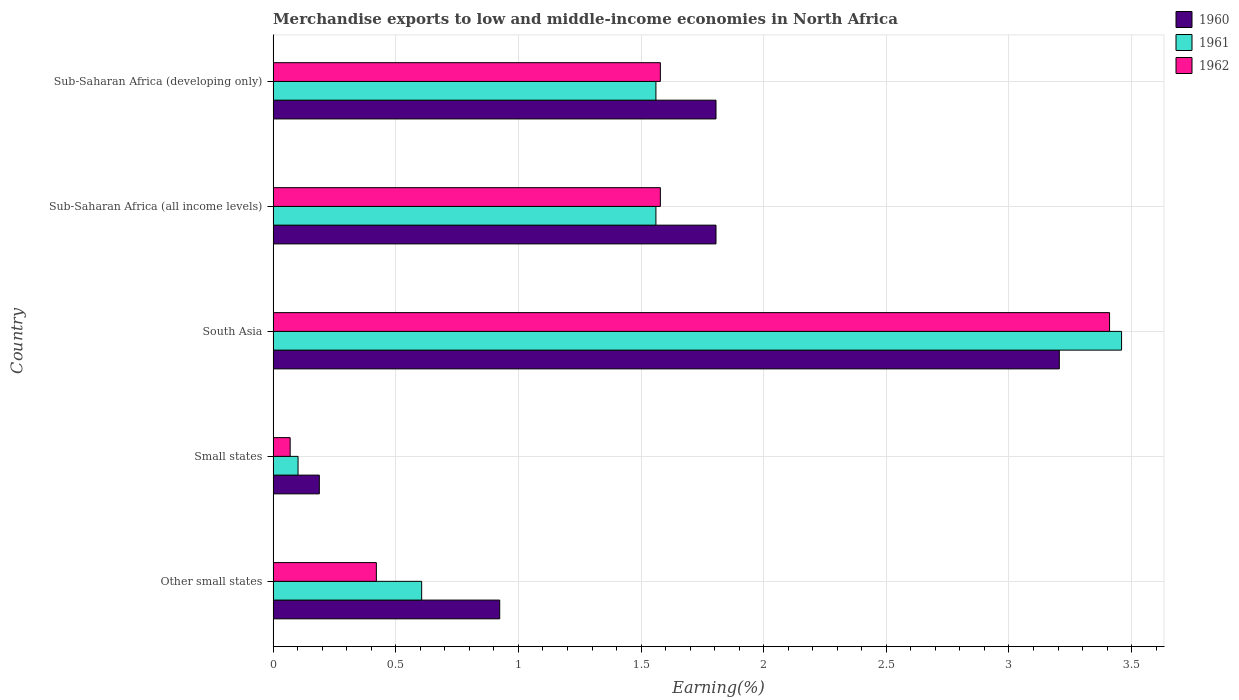How many different coloured bars are there?
Ensure brevity in your answer.  3. What is the percentage of amount earned from merchandise exports in 1962 in Other small states?
Provide a short and direct response. 0.42. Across all countries, what is the maximum percentage of amount earned from merchandise exports in 1962?
Offer a terse response. 3.41. Across all countries, what is the minimum percentage of amount earned from merchandise exports in 1961?
Provide a short and direct response. 0.1. In which country was the percentage of amount earned from merchandise exports in 1960 minimum?
Your answer should be very brief. Small states. What is the total percentage of amount earned from merchandise exports in 1960 in the graph?
Ensure brevity in your answer.  7.93. What is the difference between the percentage of amount earned from merchandise exports in 1962 in Small states and that in Sub-Saharan Africa (all income levels)?
Give a very brief answer. -1.51. What is the difference between the percentage of amount earned from merchandise exports in 1961 in Sub-Saharan Africa (developing only) and the percentage of amount earned from merchandise exports in 1962 in Sub-Saharan Africa (all income levels)?
Provide a short and direct response. -0.02. What is the average percentage of amount earned from merchandise exports in 1960 per country?
Your response must be concise. 1.59. What is the difference between the percentage of amount earned from merchandise exports in 1961 and percentage of amount earned from merchandise exports in 1960 in South Asia?
Offer a terse response. 0.25. What is the ratio of the percentage of amount earned from merchandise exports in 1960 in Small states to that in Sub-Saharan Africa (developing only)?
Make the answer very short. 0.1. Is the difference between the percentage of amount earned from merchandise exports in 1961 in Other small states and Small states greater than the difference between the percentage of amount earned from merchandise exports in 1960 in Other small states and Small states?
Ensure brevity in your answer.  No. What is the difference between the highest and the second highest percentage of amount earned from merchandise exports in 1961?
Keep it short and to the point. 1.9. What is the difference between the highest and the lowest percentage of amount earned from merchandise exports in 1960?
Keep it short and to the point. 3.02. Is the sum of the percentage of amount earned from merchandise exports in 1960 in Other small states and Sub-Saharan Africa (developing only) greater than the maximum percentage of amount earned from merchandise exports in 1962 across all countries?
Offer a very short reply. No. Is it the case that in every country, the sum of the percentage of amount earned from merchandise exports in 1961 and percentage of amount earned from merchandise exports in 1960 is greater than the percentage of amount earned from merchandise exports in 1962?
Keep it short and to the point. Yes. Are the values on the major ticks of X-axis written in scientific E-notation?
Offer a terse response. No. Where does the legend appear in the graph?
Ensure brevity in your answer.  Top right. How many legend labels are there?
Offer a terse response. 3. How are the legend labels stacked?
Give a very brief answer. Vertical. What is the title of the graph?
Your answer should be compact. Merchandise exports to low and middle-income economies in North Africa. Does "2010" appear as one of the legend labels in the graph?
Provide a succinct answer. No. What is the label or title of the X-axis?
Give a very brief answer. Earning(%). What is the Earning(%) in 1960 in Other small states?
Offer a very short reply. 0.92. What is the Earning(%) in 1961 in Other small states?
Offer a terse response. 0.61. What is the Earning(%) in 1962 in Other small states?
Your answer should be very brief. 0.42. What is the Earning(%) in 1960 in Small states?
Ensure brevity in your answer.  0.19. What is the Earning(%) of 1961 in Small states?
Offer a terse response. 0.1. What is the Earning(%) in 1962 in Small states?
Your answer should be very brief. 0.07. What is the Earning(%) in 1960 in South Asia?
Offer a terse response. 3.21. What is the Earning(%) in 1961 in South Asia?
Keep it short and to the point. 3.46. What is the Earning(%) of 1962 in South Asia?
Make the answer very short. 3.41. What is the Earning(%) in 1960 in Sub-Saharan Africa (all income levels)?
Give a very brief answer. 1.81. What is the Earning(%) in 1961 in Sub-Saharan Africa (all income levels)?
Provide a succinct answer. 1.56. What is the Earning(%) in 1962 in Sub-Saharan Africa (all income levels)?
Your answer should be compact. 1.58. What is the Earning(%) of 1960 in Sub-Saharan Africa (developing only)?
Your response must be concise. 1.81. What is the Earning(%) in 1961 in Sub-Saharan Africa (developing only)?
Ensure brevity in your answer.  1.56. What is the Earning(%) in 1962 in Sub-Saharan Africa (developing only)?
Give a very brief answer. 1.58. Across all countries, what is the maximum Earning(%) in 1960?
Offer a very short reply. 3.21. Across all countries, what is the maximum Earning(%) of 1961?
Make the answer very short. 3.46. Across all countries, what is the maximum Earning(%) of 1962?
Keep it short and to the point. 3.41. Across all countries, what is the minimum Earning(%) in 1960?
Your answer should be compact. 0.19. Across all countries, what is the minimum Earning(%) in 1961?
Make the answer very short. 0.1. Across all countries, what is the minimum Earning(%) of 1962?
Provide a short and direct response. 0.07. What is the total Earning(%) in 1960 in the graph?
Provide a short and direct response. 7.93. What is the total Earning(%) in 1961 in the graph?
Keep it short and to the point. 7.29. What is the total Earning(%) of 1962 in the graph?
Keep it short and to the point. 7.06. What is the difference between the Earning(%) in 1960 in Other small states and that in Small states?
Your answer should be very brief. 0.74. What is the difference between the Earning(%) of 1961 in Other small states and that in Small states?
Offer a terse response. 0.5. What is the difference between the Earning(%) in 1962 in Other small states and that in Small states?
Make the answer very short. 0.35. What is the difference between the Earning(%) in 1960 in Other small states and that in South Asia?
Your response must be concise. -2.28. What is the difference between the Earning(%) in 1961 in Other small states and that in South Asia?
Offer a terse response. -2.85. What is the difference between the Earning(%) of 1962 in Other small states and that in South Asia?
Your answer should be compact. -2.99. What is the difference between the Earning(%) of 1960 in Other small states and that in Sub-Saharan Africa (all income levels)?
Ensure brevity in your answer.  -0.88. What is the difference between the Earning(%) in 1961 in Other small states and that in Sub-Saharan Africa (all income levels)?
Your answer should be compact. -0.96. What is the difference between the Earning(%) in 1962 in Other small states and that in Sub-Saharan Africa (all income levels)?
Provide a short and direct response. -1.16. What is the difference between the Earning(%) of 1960 in Other small states and that in Sub-Saharan Africa (developing only)?
Offer a very short reply. -0.88. What is the difference between the Earning(%) of 1961 in Other small states and that in Sub-Saharan Africa (developing only)?
Give a very brief answer. -0.96. What is the difference between the Earning(%) in 1962 in Other small states and that in Sub-Saharan Africa (developing only)?
Your answer should be compact. -1.16. What is the difference between the Earning(%) in 1960 in Small states and that in South Asia?
Your response must be concise. -3.02. What is the difference between the Earning(%) in 1961 in Small states and that in South Asia?
Provide a succinct answer. -3.36. What is the difference between the Earning(%) of 1962 in Small states and that in South Asia?
Offer a very short reply. -3.34. What is the difference between the Earning(%) in 1960 in Small states and that in Sub-Saharan Africa (all income levels)?
Ensure brevity in your answer.  -1.62. What is the difference between the Earning(%) in 1961 in Small states and that in Sub-Saharan Africa (all income levels)?
Offer a very short reply. -1.46. What is the difference between the Earning(%) in 1962 in Small states and that in Sub-Saharan Africa (all income levels)?
Your answer should be very brief. -1.51. What is the difference between the Earning(%) of 1960 in Small states and that in Sub-Saharan Africa (developing only)?
Your response must be concise. -1.62. What is the difference between the Earning(%) in 1961 in Small states and that in Sub-Saharan Africa (developing only)?
Provide a short and direct response. -1.46. What is the difference between the Earning(%) of 1962 in Small states and that in Sub-Saharan Africa (developing only)?
Provide a short and direct response. -1.51. What is the difference between the Earning(%) in 1960 in South Asia and that in Sub-Saharan Africa (all income levels)?
Offer a very short reply. 1.4. What is the difference between the Earning(%) of 1961 in South Asia and that in Sub-Saharan Africa (all income levels)?
Your response must be concise. 1.9. What is the difference between the Earning(%) of 1962 in South Asia and that in Sub-Saharan Africa (all income levels)?
Provide a short and direct response. 1.83. What is the difference between the Earning(%) in 1960 in South Asia and that in Sub-Saharan Africa (developing only)?
Your answer should be very brief. 1.4. What is the difference between the Earning(%) of 1961 in South Asia and that in Sub-Saharan Africa (developing only)?
Offer a terse response. 1.9. What is the difference between the Earning(%) of 1962 in South Asia and that in Sub-Saharan Africa (developing only)?
Make the answer very short. 1.83. What is the difference between the Earning(%) of 1962 in Sub-Saharan Africa (all income levels) and that in Sub-Saharan Africa (developing only)?
Offer a terse response. 0. What is the difference between the Earning(%) of 1960 in Other small states and the Earning(%) of 1961 in Small states?
Give a very brief answer. 0.82. What is the difference between the Earning(%) in 1960 in Other small states and the Earning(%) in 1962 in Small states?
Provide a short and direct response. 0.85. What is the difference between the Earning(%) of 1961 in Other small states and the Earning(%) of 1962 in Small states?
Provide a short and direct response. 0.54. What is the difference between the Earning(%) of 1960 in Other small states and the Earning(%) of 1961 in South Asia?
Offer a very short reply. -2.54. What is the difference between the Earning(%) in 1960 in Other small states and the Earning(%) in 1962 in South Asia?
Keep it short and to the point. -2.49. What is the difference between the Earning(%) of 1961 in Other small states and the Earning(%) of 1962 in South Asia?
Your answer should be very brief. -2.8. What is the difference between the Earning(%) in 1960 in Other small states and the Earning(%) in 1961 in Sub-Saharan Africa (all income levels)?
Your answer should be compact. -0.64. What is the difference between the Earning(%) in 1960 in Other small states and the Earning(%) in 1962 in Sub-Saharan Africa (all income levels)?
Give a very brief answer. -0.66. What is the difference between the Earning(%) in 1961 in Other small states and the Earning(%) in 1962 in Sub-Saharan Africa (all income levels)?
Provide a short and direct response. -0.97. What is the difference between the Earning(%) of 1960 in Other small states and the Earning(%) of 1961 in Sub-Saharan Africa (developing only)?
Keep it short and to the point. -0.64. What is the difference between the Earning(%) of 1960 in Other small states and the Earning(%) of 1962 in Sub-Saharan Africa (developing only)?
Your response must be concise. -0.66. What is the difference between the Earning(%) in 1961 in Other small states and the Earning(%) in 1962 in Sub-Saharan Africa (developing only)?
Provide a short and direct response. -0.97. What is the difference between the Earning(%) in 1960 in Small states and the Earning(%) in 1961 in South Asia?
Your answer should be very brief. -3.27. What is the difference between the Earning(%) of 1960 in Small states and the Earning(%) of 1962 in South Asia?
Your response must be concise. -3.22. What is the difference between the Earning(%) of 1961 in Small states and the Earning(%) of 1962 in South Asia?
Provide a short and direct response. -3.31. What is the difference between the Earning(%) in 1960 in Small states and the Earning(%) in 1961 in Sub-Saharan Africa (all income levels)?
Provide a short and direct response. -1.37. What is the difference between the Earning(%) in 1960 in Small states and the Earning(%) in 1962 in Sub-Saharan Africa (all income levels)?
Give a very brief answer. -1.39. What is the difference between the Earning(%) of 1961 in Small states and the Earning(%) of 1962 in Sub-Saharan Africa (all income levels)?
Provide a short and direct response. -1.48. What is the difference between the Earning(%) in 1960 in Small states and the Earning(%) in 1961 in Sub-Saharan Africa (developing only)?
Your response must be concise. -1.37. What is the difference between the Earning(%) in 1960 in Small states and the Earning(%) in 1962 in Sub-Saharan Africa (developing only)?
Give a very brief answer. -1.39. What is the difference between the Earning(%) in 1961 in Small states and the Earning(%) in 1962 in Sub-Saharan Africa (developing only)?
Your response must be concise. -1.48. What is the difference between the Earning(%) in 1960 in South Asia and the Earning(%) in 1961 in Sub-Saharan Africa (all income levels)?
Give a very brief answer. 1.64. What is the difference between the Earning(%) in 1960 in South Asia and the Earning(%) in 1962 in Sub-Saharan Africa (all income levels)?
Your answer should be compact. 1.63. What is the difference between the Earning(%) of 1961 in South Asia and the Earning(%) of 1962 in Sub-Saharan Africa (all income levels)?
Offer a very short reply. 1.88. What is the difference between the Earning(%) in 1960 in South Asia and the Earning(%) in 1961 in Sub-Saharan Africa (developing only)?
Keep it short and to the point. 1.64. What is the difference between the Earning(%) in 1960 in South Asia and the Earning(%) in 1962 in Sub-Saharan Africa (developing only)?
Keep it short and to the point. 1.63. What is the difference between the Earning(%) of 1961 in South Asia and the Earning(%) of 1962 in Sub-Saharan Africa (developing only)?
Offer a terse response. 1.88. What is the difference between the Earning(%) of 1960 in Sub-Saharan Africa (all income levels) and the Earning(%) of 1961 in Sub-Saharan Africa (developing only)?
Keep it short and to the point. 0.24. What is the difference between the Earning(%) in 1960 in Sub-Saharan Africa (all income levels) and the Earning(%) in 1962 in Sub-Saharan Africa (developing only)?
Offer a very short reply. 0.23. What is the difference between the Earning(%) in 1961 in Sub-Saharan Africa (all income levels) and the Earning(%) in 1962 in Sub-Saharan Africa (developing only)?
Your response must be concise. -0.02. What is the average Earning(%) of 1960 per country?
Make the answer very short. 1.59. What is the average Earning(%) of 1961 per country?
Give a very brief answer. 1.46. What is the average Earning(%) in 1962 per country?
Your answer should be compact. 1.41. What is the difference between the Earning(%) in 1960 and Earning(%) in 1961 in Other small states?
Provide a short and direct response. 0.32. What is the difference between the Earning(%) in 1960 and Earning(%) in 1962 in Other small states?
Ensure brevity in your answer.  0.5. What is the difference between the Earning(%) in 1961 and Earning(%) in 1962 in Other small states?
Keep it short and to the point. 0.18. What is the difference between the Earning(%) in 1960 and Earning(%) in 1961 in Small states?
Give a very brief answer. 0.09. What is the difference between the Earning(%) of 1960 and Earning(%) of 1962 in Small states?
Provide a succinct answer. 0.12. What is the difference between the Earning(%) in 1961 and Earning(%) in 1962 in Small states?
Make the answer very short. 0.03. What is the difference between the Earning(%) in 1960 and Earning(%) in 1961 in South Asia?
Your answer should be very brief. -0.25. What is the difference between the Earning(%) of 1960 and Earning(%) of 1962 in South Asia?
Give a very brief answer. -0.2. What is the difference between the Earning(%) in 1961 and Earning(%) in 1962 in South Asia?
Ensure brevity in your answer.  0.05. What is the difference between the Earning(%) in 1960 and Earning(%) in 1961 in Sub-Saharan Africa (all income levels)?
Make the answer very short. 0.24. What is the difference between the Earning(%) of 1960 and Earning(%) of 1962 in Sub-Saharan Africa (all income levels)?
Ensure brevity in your answer.  0.23. What is the difference between the Earning(%) in 1961 and Earning(%) in 1962 in Sub-Saharan Africa (all income levels)?
Your answer should be very brief. -0.02. What is the difference between the Earning(%) of 1960 and Earning(%) of 1961 in Sub-Saharan Africa (developing only)?
Offer a terse response. 0.24. What is the difference between the Earning(%) in 1960 and Earning(%) in 1962 in Sub-Saharan Africa (developing only)?
Provide a succinct answer. 0.23. What is the difference between the Earning(%) in 1961 and Earning(%) in 1962 in Sub-Saharan Africa (developing only)?
Give a very brief answer. -0.02. What is the ratio of the Earning(%) in 1960 in Other small states to that in Small states?
Offer a terse response. 4.9. What is the ratio of the Earning(%) in 1961 in Other small states to that in Small states?
Your answer should be compact. 5.96. What is the ratio of the Earning(%) of 1962 in Other small states to that in Small states?
Ensure brevity in your answer.  6.06. What is the ratio of the Earning(%) of 1960 in Other small states to that in South Asia?
Your answer should be very brief. 0.29. What is the ratio of the Earning(%) in 1961 in Other small states to that in South Asia?
Provide a short and direct response. 0.18. What is the ratio of the Earning(%) in 1962 in Other small states to that in South Asia?
Provide a short and direct response. 0.12. What is the ratio of the Earning(%) of 1960 in Other small states to that in Sub-Saharan Africa (all income levels)?
Your answer should be very brief. 0.51. What is the ratio of the Earning(%) in 1961 in Other small states to that in Sub-Saharan Africa (all income levels)?
Provide a short and direct response. 0.39. What is the ratio of the Earning(%) of 1962 in Other small states to that in Sub-Saharan Africa (all income levels)?
Give a very brief answer. 0.27. What is the ratio of the Earning(%) in 1960 in Other small states to that in Sub-Saharan Africa (developing only)?
Make the answer very short. 0.51. What is the ratio of the Earning(%) in 1961 in Other small states to that in Sub-Saharan Africa (developing only)?
Make the answer very short. 0.39. What is the ratio of the Earning(%) in 1962 in Other small states to that in Sub-Saharan Africa (developing only)?
Your answer should be very brief. 0.27. What is the ratio of the Earning(%) in 1960 in Small states to that in South Asia?
Provide a short and direct response. 0.06. What is the ratio of the Earning(%) of 1961 in Small states to that in South Asia?
Your answer should be compact. 0.03. What is the ratio of the Earning(%) of 1962 in Small states to that in South Asia?
Make the answer very short. 0.02. What is the ratio of the Earning(%) in 1960 in Small states to that in Sub-Saharan Africa (all income levels)?
Your answer should be very brief. 0.1. What is the ratio of the Earning(%) in 1961 in Small states to that in Sub-Saharan Africa (all income levels)?
Offer a very short reply. 0.07. What is the ratio of the Earning(%) in 1962 in Small states to that in Sub-Saharan Africa (all income levels)?
Your answer should be very brief. 0.04. What is the ratio of the Earning(%) in 1960 in Small states to that in Sub-Saharan Africa (developing only)?
Offer a very short reply. 0.1. What is the ratio of the Earning(%) in 1961 in Small states to that in Sub-Saharan Africa (developing only)?
Give a very brief answer. 0.07. What is the ratio of the Earning(%) of 1962 in Small states to that in Sub-Saharan Africa (developing only)?
Offer a very short reply. 0.04. What is the ratio of the Earning(%) in 1960 in South Asia to that in Sub-Saharan Africa (all income levels)?
Your answer should be compact. 1.78. What is the ratio of the Earning(%) of 1961 in South Asia to that in Sub-Saharan Africa (all income levels)?
Your answer should be very brief. 2.22. What is the ratio of the Earning(%) of 1962 in South Asia to that in Sub-Saharan Africa (all income levels)?
Make the answer very short. 2.16. What is the ratio of the Earning(%) of 1960 in South Asia to that in Sub-Saharan Africa (developing only)?
Provide a short and direct response. 1.78. What is the ratio of the Earning(%) in 1961 in South Asia to that in Sub-Saharan Africa (developing only)?
Offer a terse response. 2.22. What is the ratio of the Earning(%) in 1962 in South Asia to that in Sub-Saharan Africa (developing only)?
Offer a very short reply. 2.16. What is the ratio of the Earning(%) of 1961 in Sub-Saharan Africa (all income levels) to that in Sub-Saharan Africa (developing only)?
Provide a short and direct response. 1. What is the difference between the highest and the second highest Earning(%) of 1960?
Ensure brevity in your answer.  1.4. What is the difference between the highest and the second highest Earning(%) in 1961?
Ensure brevity in your answer.  1.9. What is the difference between the highest and the second highest Earning(%) of 1962?
Ensure brevity in your answer.  1.83. What is the difference between the highest and the lowest Earning(%) of 1960?
Your response must be concise. 3.02. What is the difference between the highest and the lowest Earning(%) in 1961?
Offer a very short reply. 3.36. What is the difference between the highest and the lowest Earning(%) of 1962?
Offer a terse response. 3.34. 